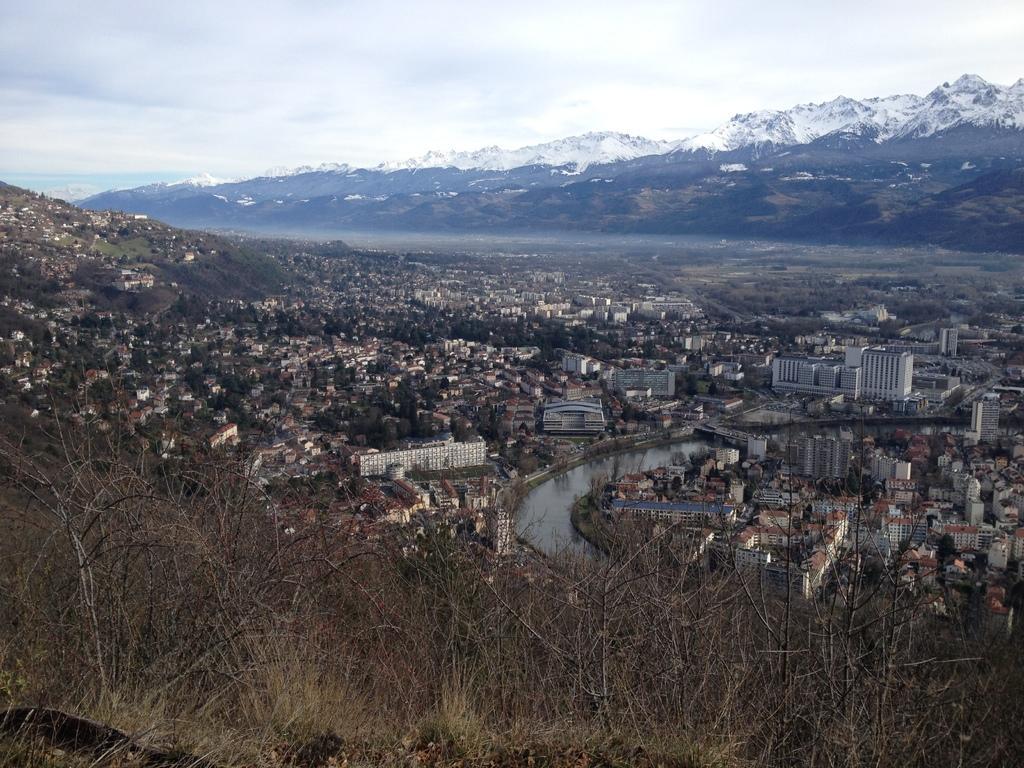How would you summarize this image in a sentence or two? In this picture we can see buildings, trees, and water. In the background we can see a mountain and sky. 